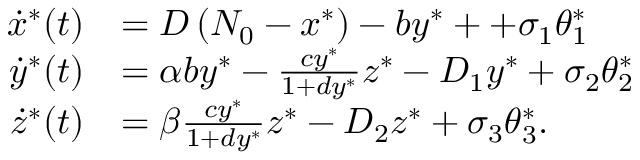<formula> <loc_0><loc_0><loc_500><loc_500>\begin{array} { r l } { \dot { x } ^ { * } ( t ) } & { = D \left ( N _ { 0 } - x ^ { * } \right ) - b y ^ { * } + + \sigma _ { 1 } \theta _ { 1 } ^ { * } } \\ { \dot { y } ^ { * } ( t ) } & { = \alpha b y ^ { * } - \frac { c y ^ { * } } { 1 + d y ^ { * } } z ^ { * } - D _ { 1 } y ^ { * } + \sigma _ { 2 } \theta _ { 2 } ^ { * } } \\ { \dot { z } ^ { * } ( t ) } & { = \beta \frac { c y ^ { * } } { 1 + d y ^ { * } } z ^ { * } - D _ { 2 } z ^ { * } + \sigma _ { 3 } \theta _ { 3 } ^ { * } . } \end{array}</formula> 